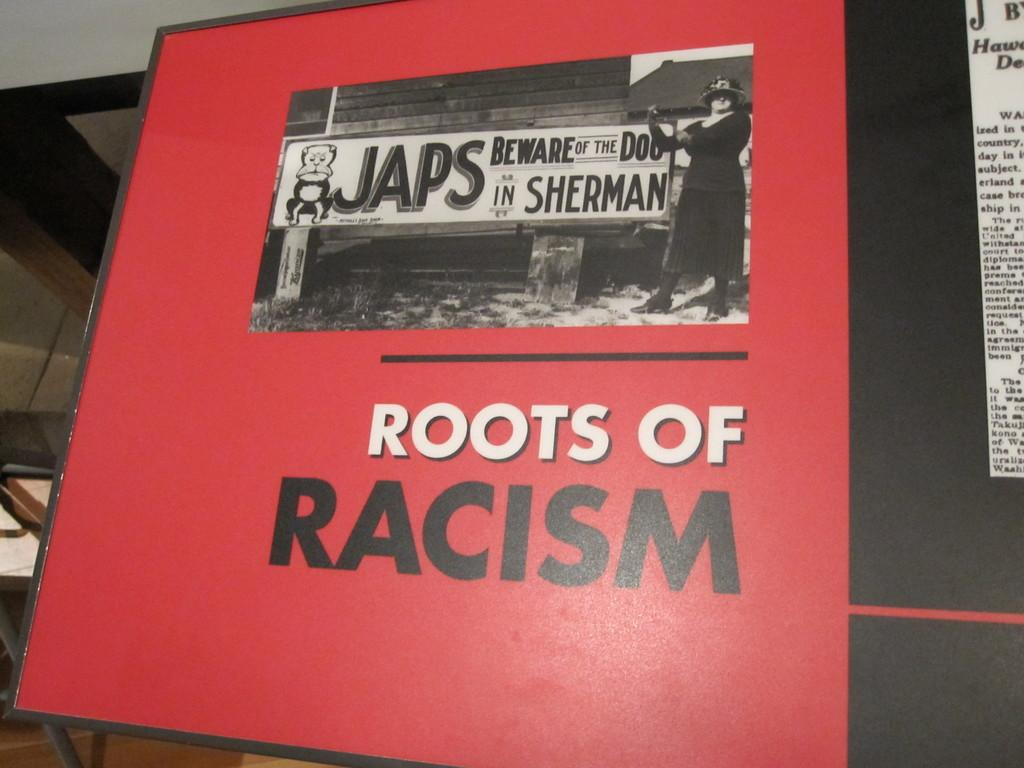What is the main subject in the image? There is a hoarding in the image. What colors are used on the hoarding? The hoarding is red and black in color. Where is the hoarding located? The hoarding is present on a wall. Can you see any veins on the hoarding in the image? There are no veins present on the hoarding in the image, as it is a flat, printed surface. 